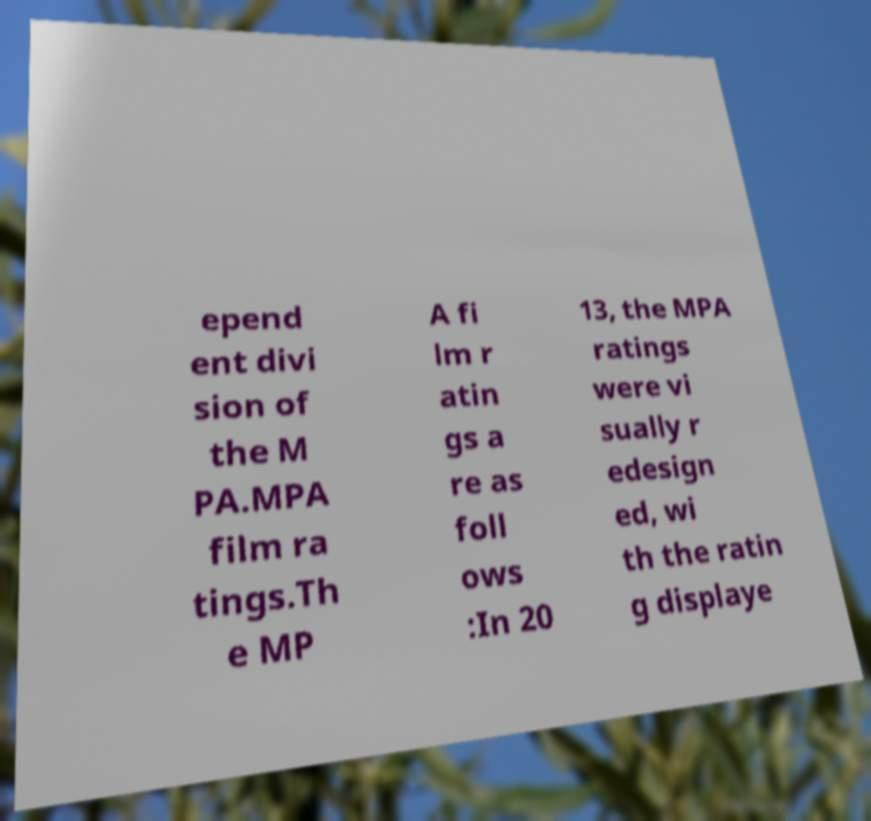What messages or text are displayed in this image? I need them in a readable, typed format. epend ent divi sion of the M PA.MPA film ra tings.Th e MP A fi lm r atin gs a re as foll ows :In 20 13, the MPA ratings were vi sually r edesign ed, wi th the ratin g displaye 